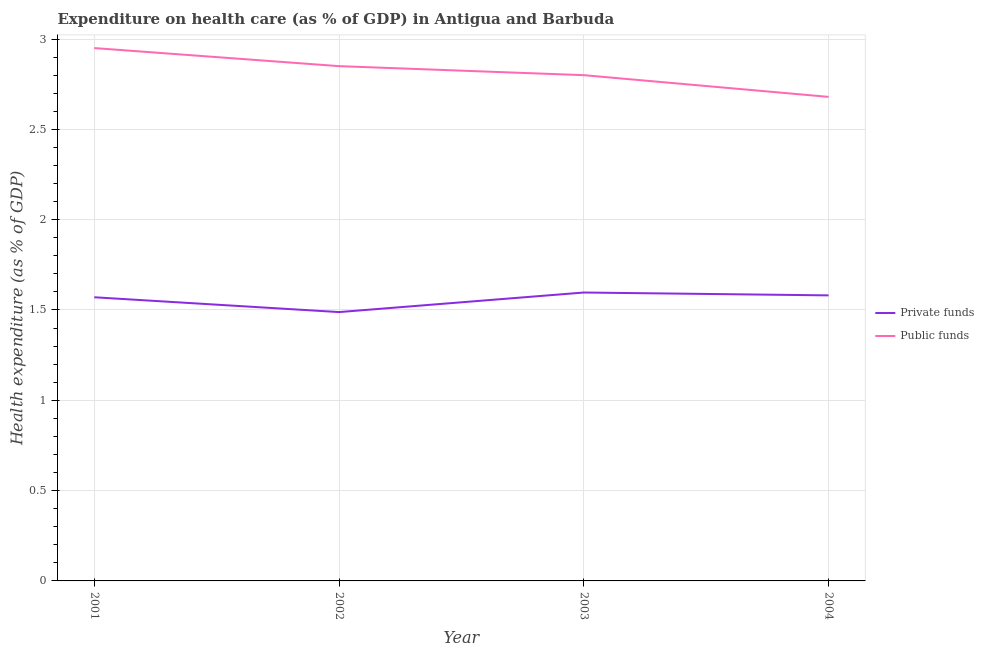Is the number of lines equal to the number of legend labels?
Your answer should be very brief. Yes. What is the amount of private funds spent in healthcare in 2001?
Offer a very short reply. 1.57. Across all years, what is the maximum amount of private funds spent in healthcare?
Provide a short and direct response. 1.6. Across all years, what is the minimum amount of private funds spent in healthcare?
Your answer should be compact. 1.49. In which year was the amount of public funds spent in healthcare maximum?
Ensure brevity in your answer.  2001. What is the total amount of public funds spent in healthcare in the graph?
Offer a very short reply. 11.28. What is the difference between the amount of public funds spent in healthcare in 2002 and that in 2004?
Keep it short and to the point. 0.17. What is the difference between the amount of private funds spent in healthcare in 2003 and the amount of public funds spent in healthcare in 2002?
Keep it short and to the point. -1.25. What is the average amount of public funds spent in healthcare per year?
Make the answer very short. 2.82. In the year 2004, what is the difference between the amount of private funds spent in healthcare and amount of public funds spent in healthcare?
Make the answer very short. -1.1. What is the ratio of the amount of public funds spent in healthcare in 2001 to that in 2004?
Ensure brevity in your answer.  1.1. Is the amount of public funds spent in healthcare in 2001 less than that in 2002?
Make the answer very short. No. Is the difference between the amount of public funds spent in healthcare in 2001 and 2003 greater than the difference between the amount of private funds spent in healthcare in 2001 and 2003?
Your answer should be very brief. Yes. What is the difference between the highest and the second highest amount of private funds spent in healthcare?
Offer a terse response. 0.02. What is the difference between the highest and the lowest amount of private funds spent in healthcare?
Ensure brevity in your answer.  0.11. In how many years, is the amount of private funds spent in healthcare greater than the average amount of private funds spent in healthcare taken over all years?
Provide a succinct answer. 3. Is the sum of the amount of private funds spent in healthcare in 2001 and 2002 greater than the maximum amount of public funds spent in healthcare across all years?
Your answer should be very brief. Yes. Does the amount of private funds spent in healthcare monotonically increase over the years?
Your response must be concise. No. Is the amount of private funds spent in healthcare strictly less than the amount of public funds spent in healthcare over the years?
Provide a short and direct response. Yes. How many years are there in the graph?
Make the answer very short. 4. What is the difference between two consecutive major ticks on the Y-axis?
Your answer should be very brief. 0.5. Does the graph contain any zero values?
Provide a succinct answer. No. Does the graph contain grids?
Keep it short and to the point. Yes. How many legend labels are there?
Provide a succinct answer. 2. What is the title of the graph?
Provide a short and direct response. Expenditure on health care (as % of GDP) in Antigua and Barbuda. What is the label or title of the Y-axis?
Ensure brevity in your answer.  Health expenditure (as % of GDP). What is the Health expenditure (as % of GDP) of Private funds in 2001?
Offer a very short reply. 1.57. What is the Health expenditure (as % of GDP) in Public funds in 2001?
Provide a succinct answer. 2.95. What is the Health expenditure (as % of GDP) of Private funds in 2002?
Provide a succinct answer. 1.49. What is the Health expenditure (as % of GDP) in Public funds in 2002?
Your response must be concise. 2.85. What is the Health expenditure (as % of GDP) in Private funds in 2003?
Provide a short and direct response. 1.6. What is the Health expenditure (as % of GDP) in Public funds in 2003?
Keep it short and to the point. 2.8. What is the Health expenditure (as % of GDP) in Private funds in 2004?
Offer a terse response. 1.58. What is the Health expenditure (as % of GDP) of Public funds in 2004?
Your response must be concise. 2.68. Across all years, what is the maximum Health expenditure (as % of GDP) in Private funds?
Offer a terse response. 1.6. Across all years, what is the maximum Health expenditure (as % of GDP) in Public funds?
Your response must be concise. 2.95. Across all years, what is the minimum Health expenditure (as % of GDP) in Private funds?
Offer a terse response. 1.49. Across all years, what is the minimum Health expenditure (as % of GDP) of Public funds?
Provide a short and direct response. 2.68. What is the total Health expenditure (as % of GDP) in Private funds in the graph?
Keep it short and to the point. 6.24. What is the total Health expenditure (as % of GDP) of Public funds in the graph?
Make the answer very short. 11.28. What is the difference between the Health expenditure (as % of GDP) in Private funds in 2001 and that in 2002?
Give a very brief answer. 0.08. What is the difference between the Health expenditure (as % of GDP) of Public funds in 2001 and that in 2002?
Provide a short and direct response. 0.1. What is the difference between the Health expenditure (as % of GDP) of Private funds in 2001 and that in 2003?
Offer a terse response. -0.03. What is the difference between the Health expenditure (as % of GDP) of Private funds in 2001 and that in 2004?
Give a very brief answer. -0.01. What is the difference between the Health expenditure (as % of GDP) of Public funds in 2001 and that in 2004?
Provide a short and direct response. 0.27. What is the difference between the Health expenditure (as % of GDP) of Private funds in 2002 and that in 2003?
Ensure brevity in your answer.  -0.11. What is the difference between the Health expenditure (as % of GDP) of Public funds in 2002 and that in 2003?
Your answer should be compact. 0.05. What is the difference between the Health expenditure (as % of GDP) in Private funds in 2002 and that in 2004?
Provide a succinct answer. -0.09. What is the difference between the Health expenditure (as % of GDP) in Public funds in 2002 and that in 2004?
Your answer should be compact. 0.17. What is the difference between the Health expenditure (as % of GDP) in Private funds in 2003 and that in 2004?
Your answer should be very brief. 0.02. What is the difference between the Health expenditure (as % of GDP) in Public funds in 2003 and that in 2004?
Your answer should be compact. 0.12. What is the difference between the Health expenditure (as % of GDP) in Private funds in 2001 and the Health expenditure (as % of GDP) in Public funds in 2002?
Offer a terse response. -1.28. What is the difference between the Health expenditure (as % of GDP) of Private funds in 2001 and the Health expenditure (as % of GDP) of Public funds in 2003?
Your answer should be very brief. -1.23. What is the difference between the Health expenditure (as % of GDP) in Private funds in 2001 and the Health expenditure (as % of GDP) in Public funds in 2004?
Provide a succinct answer. -1.11. What is the difference between the Health expenditure (as % of GDP) in Private funds in 2002 and the Health expenditure (as % of GDP) in Public funds in 2003?
Provide a succinct answer. -1.31. What is the difference between the Health expenditure (as % of GDP) of Private funds in 2002 and the Health expenditure (as % of GDP) of Public funds in 2004?
Offer a very short reply. -1.19. What is the difference between the Health expenditure (as % of GDP) of Private funds in 2003 and the Health expenditure (as % of GDP) of Public funds in 2004?
Keep it short and to the point. -1.08. What is the average Health expenditure (as % of GDP) of Private funds per year?
Ensure brevity in your answer.  1.56. What is the average Health expenditure (as % of GDP) of Public funds per year?
Offer a terse response. 2.82. In the year 2001, what is the difference between the Health expenditure (as % of GDP) of Private funds and Health expenditure (as % of GDP) of Public funds?
Keep it short and to the point. -1.38. In the year 2002, what is the difference between the Health expenditure (as % of GDP) in Private funds and Health expenditure (as % of GDP) in Public funds?
Offer a terse response. -1.36. In the year 2003, what is the difference between the Health expenditure (as % of GDP) in Private funds and Health expenditure (as % of GDP) in Public funds?
Offer a very short reply. -1.2. In the year 2004, what is the difference between the Health expenditure (as % of GDP) of Private funds and Health expenditure (as % of GDP) of Public funds?
Your answer should be very brief. -1.1. What is the ratio of the Health expenditure (as % of GDP) of Private funds in 2001 to that in 2002?
Provide a succinct answer. 1.06. What is the ratio of the Health expenditure (as % of GDP) of Public funds in 2001 to that in 2002?
Make the answer very short. 1.04. What is the ratio of the Health expenditure (as % of GDP) of Private funds in 2001 to that in 2003?
Your answer should be very brief. 0.98. What is the ratio of the Health expenditure (as % of GDP) in Public funds in 2001 to that in 2003?
Your answer should be compact. 1.05. What is the ratio of the Health expenditure (as % of GDP) in Public funds in 2001 to that in 2004?
Provide a short and direct response. 1.1. What is the ratio of the Health expenditure (as % of GDP) in Private funds in 2002 to that in 2003?
Your answer should be compact. 0.93. What is the ratio of the Health expenditure (as % of GDP) in Public funds in 2002 to that in 2003?
Offer a very short reply. 1.02. What is the ratio of the Health expenditure (as % of GDP) in Private funds in 2002 to that in 2004?
Keep it short and to the point. 0.94. What is the ratio of the Health expenditure (as % of GDP) in Public funds in 2002 to that in 2004?
Your answer should be very brief. 1.06. What is the ratio of the Health expenditure (as % of GDP) in Public funds in 2003 to that in 2004?
Ensure brevity in your answer.  1.04. What is the difference between the highest and the second highest Health expenditure (as % of GDP) in Private funds?
Provide a succinct answer. 0.02. What is the difference between the highest and the lowest Health expenditure (as % of GDP) in Private funds?
Your answer should be compact. 0.11. What is the difference between the highest and the lowest Health expenditure (as % of GDP) in Public funds?
Your answer should be very brief. 0.27. 